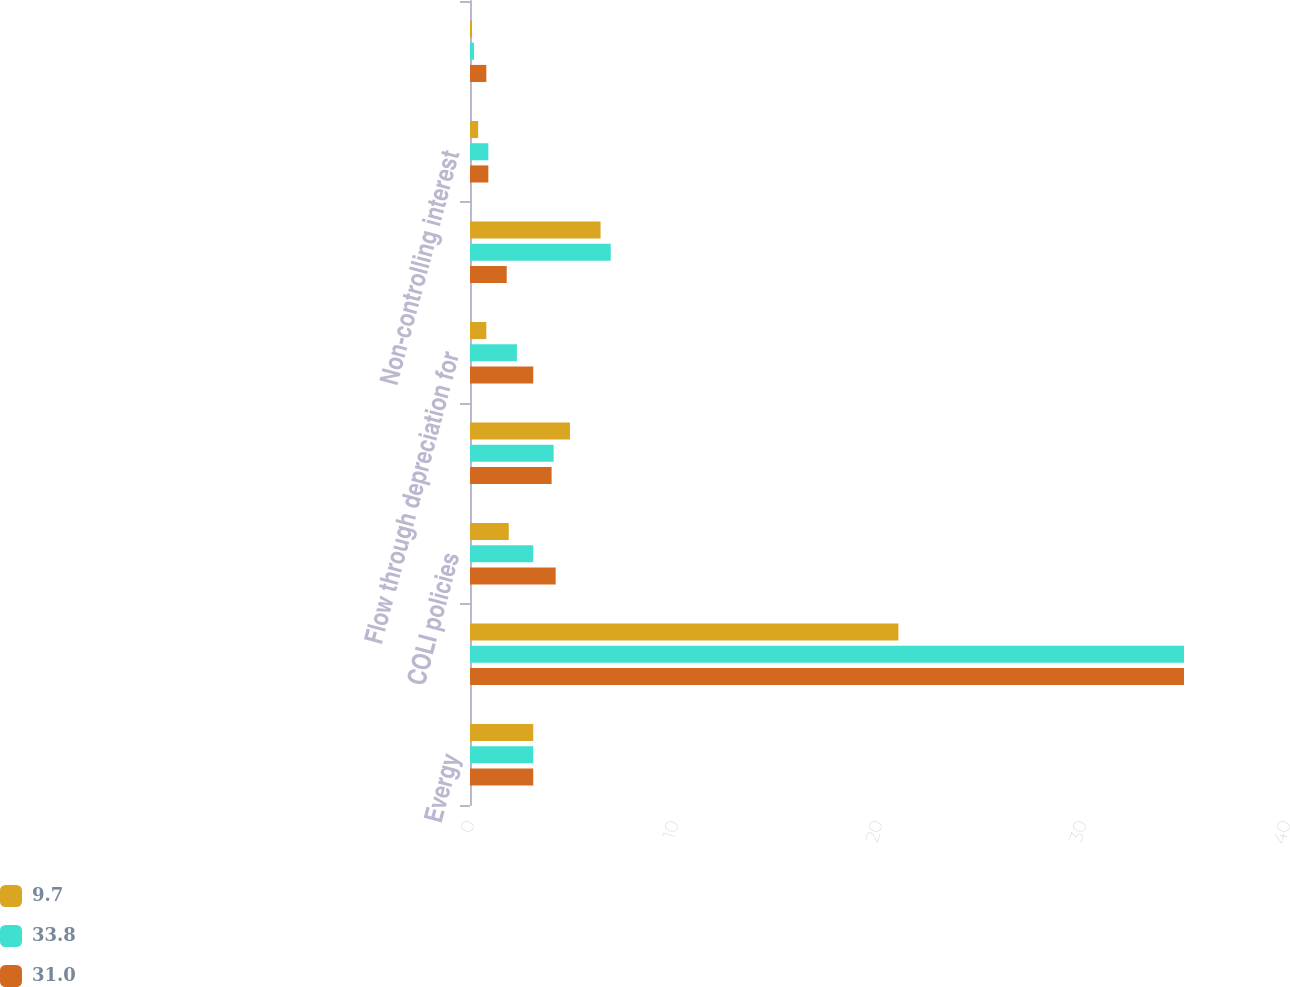<chart> <loc_0><loc_0><loc_500><loc_500><stacked_bar_chart><ecel><fcel>Evergy<fcel>Federal statutory income tax<fcel>COLI policies<fcel>State income taxes<fcel>Flow through depreciation for<fcel>Federal tax credits<fcel>Non-controlling interest<fcel>AFUDC equity<nl><fcel>9.7<fcel>3.1<fcel>21<fcel>1.9<fcel>4.9<fcel>0.8<fcel>6.4<fcel>0.4<fcel>0.1<nl><fcel>33.8<fcel>3.1<fcel>35<fcel>3.1<fcel>4.1<fcel>2.3<fcel>6.9<fcel>0.9<fcel>0.2<nl><fcel>31<fcel>3.1<fcel>35<fcel>4.2<fcel>4<fcel>3.1<fcel>1.8<fcel>0.9<fcel>0.8<nl></chart> 